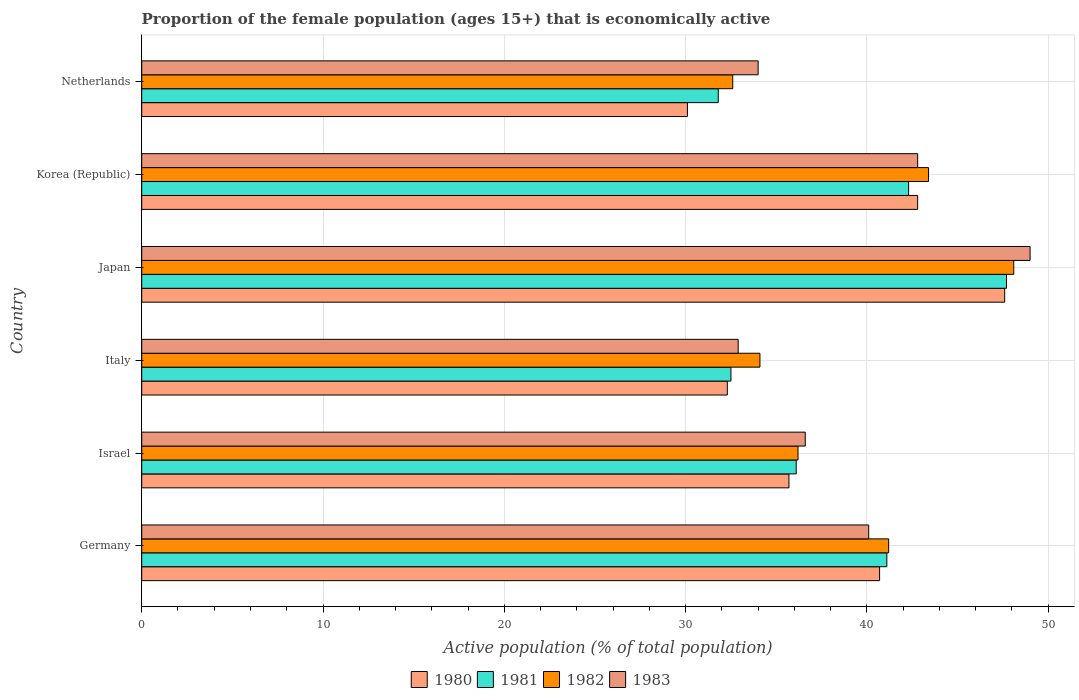In how many cases, is the number of bars for a given country not equal to the number of legend labels?
Your answer should be very brief. 0. What is the proportion of the female population that is economically active in 1983 in Germany?
Make the answer very short. 40.1. Across all countries, what is the maximum proportion of the female population that is economically active in 1982?
Your response must be concise. 48.1. Across all countries, what is the minimum proportion of the female population that is economically active in 1983?
Offer a terse response. 32.9. In which country was the proportion of the female population that is economically active in 1982 maximum?
Give a very brief answer. Japan. What is the total proportion of the female population that is economically active in 1982 in the graph?
Provide a short and direct response. 235.6. What is the difference between the proportion of the female population that is economically active in 1980 in Germany and that in Korea (Republic)?
Offer a terse response. -2.1. What is the difference between the proportion of the female population that is economically active in 1981 in Israel and the proportion of the female population that is economically active in 1980 in Germany?
Give a very brief answer. -4.6. What is the average proportion of the female population that is economically active in 1982 per country?
Your answer should be very brief. 39.27. What is the difference between the proportion of the female population that is economically active in 1983 and proportion of the female population that is economically active in 1982 in Germany?
Keep it short and to the point. -1.1. In how many countries, is the proportion of the female population that is economically active in 1980 greater than 6 %?
Offer a terse response. 6. What is the ratio of the proportion of the female population that is economically active in 1983 in Italy to that in Korea (Republic)?
Give a very brief answer. 0.77. Is the proportion of the female population that is economically active in 1983 in Germany less than that in Korea (Republic)?
Keep it short and to the point. Yes. What is the difference between the highest and the second highest proportion of the female population that is economically active in 1982?
Your response must be concise. 4.7. What is the difference between the highest and the lowest proportion of the female population that is economically active in 1980?
Your answer should be very brief. 17.5. In how many countries, is the proportion of the female population that is economically active in 1981 greater than the average proportion of the female population that is economically active in 1981 taken over all countries?
Ensure brevity in your answer.  3. Is the sum of the proportion of the female population that is economically active in 1982 in Korea (Republic) and Netherlands greater than the maximum proportion of the female population that is economically active in 1980 across all countries?
Your answer should be very brief. Yes. What does the 1st bar from the bottom in Korea (Republic) represents?
Your answer should be very brief. 1980. Is it the case that in every country, the sum of the proportion of the female population that is economically active in 1981 and proportion of the female population that is economically active in 1980 is greater than the proportion of the female population that is economically active in 1982?
Offer a terse response. Yes. How many bars are there?
Your answer should be very brief. 24. How many countries are there in the graph?
Keep it short and to the point. 6. What is the difference between two consecutive major ticks on the X-axis?
Offer a terse response. 10. Does the graph contain grids?
Offer a very short reply. Yes. Where does the legend appear in the graph?
Your response must be concise. Bottom center. How are the legend labels stacked?
Make the answer very short. Horizontal. What is the title of the graph?
Give a very brief answer. Proportion of the female population (ages 15+) that is economically active. Does "1973" appear as one of the legend labels in the graph?
Make the answer very short. No. What is the label or title of the X-axis?
Offer a terse response. Active population (% of total population). What is the label or title of the Y-axis?
Make the answer very short. Country. What is the Active population (% of total population) of 1980 in Germany?
Offer a very short reply. 40.7. What is the Active population (% of total population) of 1981 in Germany?
Ensure brevity in your answer.  41.1. What is the Active population (% of total population) of 1982 in Germany?
Make the answer very short. 41.2. What is the Active population (% of total population) in 1983 in Germany?
Keep it short and to the point. 40.1. What is the Active population (% of total population) of 1980 in Israel?
Make the answer very short. 35.7. What is the Active population (% of total population) of 1981 in Israel?
Offer a very short reply. 36.1. What is the Active population (% of total population) in 1982 in Israel?
Provide a short and direct response. 36.2. What is the Active population (% of total population) of 1983 in Israel?
Provide a succinct answer. 36.6. What is the Active population (% of total population) of 1980 in Italy?
Ensure brevity in your answer.  32.3. What is the Active population (% of total population) in 1981 in Italy?
Give a very brief answer. 32.5. What is the Active population (% of total population) of 1982 in Italy?
Make the answer very short. 34.1. What is the Active population (% of total population) in 1983 in Italy?
Provide a short and direct response. 32.9. What is the Active population (% of total population) of 1980 in Japan?
Make the answer very short. 47.6. What is the Active population (% of total population) of 1981 in Japan?
Keep it short and to the point. 47.7. What is the Active population (% of total population) in 1982 in Japan?
Your answer should be compact. 48.1. What is the Active population (% of total population) in 1980 in Korea (Republic)?
Your response must be concise. 42.8. What is the Active population (% of total population) of 1981 in Korea (Republic)?
Your answer should be very brief. 42.3. What is the Active population (% of total population) in 1982 in Korea (Republic)?
Give a very brief answer. 43.4. What is the Active population (% of total population) of 1983 in Korea (Republic)?
Give a very brief answer. 42.8. What is the Active population (% of total population) of 1980 in Netherlands?
Offer a very short reply. 30.1. What is the Active population (% of total population) in 1981 in Netherlands?
Give a very brief answer. 31.8. What is the Active population (% of total population) in 1982 in Netherlands?
Provide a short and direct response. 32.6. Across all countries, what is the maximum Active population (% of total population) of 1980?
Provide a short and direct response. 47.6. Across all countries, what is the maximum Active population (% of total population) of 1981?
Keep it short and to the point. 47.7. Across all countries, what is the maximum Active population (% of total population) in 1982?
Offer a terse response. 48.1. Across all countries, what is the maximum Active population (% of total population) of 1983?
Offer a terse response. 49. Across all countries, what is the minimum Active population (% of total population) in 1980?
Your answer should be compact. 30.1. Across all countries, what is the minimum Active population (% of total population) of 1981?
Your answer should be very brief. 31.8. Across all countries, what is the minimum Active population (% of total population) in 1982?
Make the answer very short. 32.6. Across all countries, what is the minimum Active population (% of total population) in 1983?
Ensure brevity in your answer.  32.9. What is the total Active population (% of total population) in 1980 in the graph?
Give a very brief answer. 229.2. What is the total Active population (% of total population) of 1981 in the graph?
Your answer should be compact. 231.5. What is the total Active population (% of total population) in 1982 in the graph?
Provide a succinct answer. 235.6. What is the total Active population (% of total population) of 1983 in the graph?
Give a very brief answer. 235.4. What is the difference between the Active population (% of total population) in 1981 in Germany and that in Israel?
Offer a very short reply. 5. What is the difference between the Active population (% of total population) of 1982 in Germany and that in Israel?
Give a very brief answer. 5. What is the difference between the Active population (% of total population) of 1983 in Germany and that in Israel?
Offer a terse response. 3.5. What is the difference between the Active population (% of total population) in 1981 in Germany and that in Italy?
Keep it short and to the point. 8.6. What is the difference between the Active population (% of total population) of 1983 in Germany and that in Italy?
Your response must be concise. 7.2. What is the difference between the Active population (% of total population) of 1981 in Germany and that in Japan?
Make the answer very short. -6.6. What is the difference between the Active population (% of total population) of 1983 in Germany and that in Japan?
Offer a very short reply. -8.9. What is the difference between the Active population (% of total population) in 1980 in Germany and that in Netherlands?
Offer a terse response. 10.6. What is the difference between the Active population (% of total population) of 1982 in Germany and that in Netherlands?
Offer a very short reply. 8.6. What is the difference between the Active population (% of total population) in 1982 in Israel and that in Italy?
Provide a short and direct response. 2.1. What is the difference between the Active population (% of total population) of 1983 in Israel and that in Italy?
Provide a succinct answer. 3.7. What is the difference between the Active population (% of total population) of 1981 in Israel and that in Japan?
Your answer should be very brief. -11.6. What is the difference between the Active population (% of total population) of 1980 in Israel and that in Netherlands?
Offer a terse response. 5.6. What is the difference between the Active population (% of total population) of 1981 in Israel and that in Netherlands?
Offer a terse response. 4.3. What is the difference between the Active population (% of total population) of 1982 in Israel and that in Netherlands?
Provide a short and direct response. 3.6. What is the difference between the Active population (% of total population) of 1980 in Italy and that in Japan?
Your answer should be very brief. -15.3. What is the difference between the Active population (% of total population) of 1981 in Italy and that in Japan?
Your answer should be very brief. -15.2. What is the difference between the Active population (% of total population) of 1982 in Italy and that in Japan?
Give a very brief answer. -14. What is the difference between the Active population (% of total population) in 1983 in Italy and that in Japan?
Ensure brevity in your answer.  -16.1. What is the difference between the Active population (% of total population) of 1983 in Italy and that in Korea (Republic)?
Provide a succinct answer. -9.9. What is the difference between the Active population (% of total population) of 1981 in Italy and that in Netherlands?
Your answer should be very brief. 0.7. What is the difference between the Active population (% of total population) in 1982 in Italy and that in Netherlands?
Offer a very short reply. 1.5. What is the difference between the Active population (% of total population) of 1983 in Italy and that in Netherlands?
Provide a succinct answer. -1.1. What is the difference between the Active population (% of total population) in 1980 in Japan and that in Korea (Republic)?
Ensure brevity in your answer.  4.8. What is the difference between the Active population (% of total population) of 1983 in Japan and that in Korea (Republic)?
Offer a terse response. 6.2. What is the difference between the Active population (% of total population) in 1980 in Japan and that in Netherlands?
Offer a very short reply. 17.5. What is the difference between the Active population (% of total population) in 1981 in Japan and that in Netherlands?
Your response must be concise. 15.9. What is the difference between the Active population (% of total population) in 1980 in Korea (Republic) and that in Netherlands?
Give a very brief answer. 12.7. What is the difference between the Active population (% of total population) of 1981 in Korea (Republic) and that in Netherlands?
Provide a short and direct response. 10.5. What is the difference between the Active population (% of total population) in 1980 in Germany and the Active population (% of total population) in 1981 in Israel?
Make the answer very short. 4.6. What is the difference between the Active population (% of total population) in 1980 in Germany and the Active population (% of total population) in 1982 in Israel?
Give a very brief answer. 4.5. What is the difference between the Active population (% of total population) in 1981 in Germany and the Active population (% of total population) in 1982 in Israel?
Ensure brevity in your answer.  4.9. What is the difference between the Active population (% of total population) of 1980 in Germany and the Active population (% of total population) of 1981 in Italy?
Your answer should be compact. 8.2. What is the difference between the Active population (% of total population) in 1980 in Germany and the Active population (% of total population) in 1982 in Italy?
Your answer should be very brief. 6.6. What is the difference between the Active population (% of total population) in 1980 in Germany and the Active population (% of total population) in 1983 in Italy?
Offer a very short reply. 7.8. What is the difference between the Active population (% of total population) of 1981 in Germany and the Active population (% of total population) of 1982 in Italy?
Offer a terse response. 7. What is the difference between the Active population (% of total population) in 1981 in Germany and the Active population (% of total population) in 1983 in Italy?
Your response must be concise. 8.2. What is the difference between the Active population (% of total population) of 1982 in Germany and the Active population (% of total population) of 1983 in Italy?
Offer a terse response. 8.3. What is the difference between the Active population (% of total population) in 1980 in Germany and the Active population (% of total population) in 1981 in Japan?
Offer a terse response. -7. What is the difference between the Active population (% of total population) of 1980 in Germany and the Active population (% of total population) of 1982 in Japan?
Your answer should be compact. -7.4. What is the difference between the Active population (% of total population) of 1980 in Germany and the Active population (% of total population) of 1983 in Japan?
Provide a short and direct response. -8.3. What is the difference between the Active population (% of total population) in 1982 in Germany and the Active population (% of total population) in 1983 in Japan?
Make the answer very short. -7.8. What is the difference between the Active population (% of total population) of 1980 in Germany and the Active population (% of total population) of 1981 in Korea (Republic)?
Offer a terse response. -1.6. What is the difference between the Active population (% of total population) of 1982 in Germany and the Active population (% of total population) of 1983 in Korea (Republic)?
Keep it short and to the point. -1.6. What is the difference between the Active population (% of total population) of 1980 in Germany and the Active population (% of total population) of 1981 in Netherlands?
Offer a terse response. 8.9. What is the difference between the Active population (% of total population) in 1980 in Germany and the Active population (% of total population) in 1982 in Netherlands?
Ensure brevity in your answer.  8.1. What is the difference between the Active population (% of total population) of 1980 in Germany and the Active population (% of total population) of 1983 in Netherlands?
Provide a short and direct response. 6.7. What is the difference between the Active population (% of total population) in 1982 in Germany and the Active population (% of total population) in 1983 in Netherlands?
Keep it short and to the point. 7.2. What is the difference between the Active population (% of total population) in 1980 in Israel and the Active population (% of total population) in 1981 in Italy?
Your response must be concise. 3.2. What is the difference between the Active population (% of total population) of 1980 in Israel and the Active population (% of total population) of 1982 in Italy?
Offer a very short reply. 1.6. What is the difference between the Active population (% of total population) in 1981 in Israel and the Active population (% of total population) in 1983 in Italy?
Offer a very short reply. 3.2. What is the difference between the Active population (% of total population) of 1982 in Israel and the Active population (% of total population) of 1983 in Italy?
Your response must be concise. 3.3. What is the difference between the Active population (% of total population) in 1980 in Israel and the Active population (% of total population) in 1983 in Japan?
Provide a short and direct response. -13.3. What is the difference between the Active population (% of total population) in 1981 in Israel and the Active population (% of total population) in 1983 in Japan?
Give a very brief answer. -12.9. What is the difference between the Active population (% of total population) of 1980 in Israel and the Active population (% of total population) of 1981 in Korea (Republic)?
Provide a succinct answer. -6.6. What is the difference between the Active population (% of total population) of 1980 in Israel and the Active population (% of total population) of 1982 in Korea (Republic)?
Offer a very short reply. -7.7. What is the difference between the Active population (% of total population) in 1980 in Israel and the Active population (% of total population) in 1983 in Korea (Republic)?
Keep it short and to the point. -7.1. What is the difference between the Active population (% of total population) in 1981 in Israel and the Active population (% of total population) in 1982 in Korea (Republic)?
Ensure brevity in your answer.  -7.3. What is the difference between the Active population (% of total population) of 1981 in Israel and the Active population (% of total population) of 1983 in Korea (Republic)?
Give a very brief answer. -6.7. What is the difference between the Active population (% of total population) in 1980 in Israel and the Active population (% of total population) in 1983 in Netherlands?
Provide a succinct answer. 1.7. What is the difference between the Active population (% of total population) of 1981 in Israel and the Active population (% of total population) of 1983 in Netherlands?
Ensure brevity in your answer.  2.1. What is the difference between the Active population (% of total population) of 1982 in Israel and the Active population (% of total population) of 1983 in Netherlands?
Provide a succinct answer. 2.2. What is the difference between the Active population (% of total population) in 1980 in Italy and the Active population (% of total population) in 1981 in Japan?
Offer a terse response. -15.4. What is the difference between the Active population (% of total population) of 1980 in Italy and the Active population (% of total population) of 1982 in Japan?
Keep it short and to the point. -15.8. What is the difference between the Active population (% of total population) of 1980 in Italy and the Active population (% of total population) of 1983 in Japan?
Keep it short and to the point. -16.7. What is the difference between the Active population (% of total population) of 1981 in Italy and the Active population (% of total population) of 1982 in Japan?
Provide a short and direct response. -15.6. What is the difference between the Active population (% of total population) of 1981 in Italy and the Active population (% of total population) of 1983 in Japan?
Your answer should be very brief. -16.5. What is the difference between the Active population (% of total population) of 1982 in Italy and the Active population (% of total population) of 1983 in Japan?
Keep it short and to the point. -14.9. What is the difference between the Active population (% of total population) of 1980 in Italy and the Active population (% of total population) of 1983 in Korea (Republic)?
Make the answer very short. -10.5. What is the difference between the Active population (% of total population) in 1981 in Italy and the Active population (% of total population) in 1982 in Korea (Republic)?
Your answer should be very brief. -10.9. What is the difference between the Active population (% of total population) of 1982 in Italy and the Active population (% of total population) of 1983 in Korea (Republic)?
Make the answer very short. -8.7. What is the difference between the Active population (% of total population) in 1980 in Italy and the Active population (% of total population) in 1981 in Netherlands?
Offer a terse response. 0.5. What is the difference between the Active population (% of total population) of 1981 in Italy and the Active population (% of total population) of 1983 in Netherlands?
Provide a succinct answer. -1.5. What is the difference between the Active population (% of total population) of 1982 in Italy and the Active population (% of total population) of 1983 in Netherlands?
Your response must be concise. 0.1. What is the difference between the Active population (% of total population) of 1980 in Japan and the Active population (% of total population) of 1981 in Korea (Republic)?
Give a very brief answer. 5.3. What is the difference between the Active population (% of total population) in 1981 in Japan and the Active population (% of total population) in 1982 in Korea (Republic)?
Provide a succinct answer. 4.3. What is the difference between the Active population (% of total population) of 1982 in Japan and the Active population (% of total population) of 1983 in Korea (Republic)?
Make the answer very short. 5.3. What is the difference between the Active population (% of total population) in 1980 in Japan and the Active population (% of total population) in 1983 in Netherlands?
Provide a succinct answer. 13.6. What is the difference between the Active population (% of total population) in 1981 in Japan and the Active population (% of total population) in 1982 in Netherlands?
Offer a very short reply. 15.1. What is the difference between the Active population (% of total population) in 1981 in Japan and the Active population (% of total population) in 1983 in Netherlands?
Provide a succinct answer. 13.7. What is the difference between the Active population (% of total population) of 1982 in Japan and the Active population (% of total population) of 1983 in Netherlands?
Your answer should be compact. 14.1. What is the difference between the Active population (% of total population) of 1980 in Korea (Republic) and the Active population (% of total population) of 1981 in Netherlands?
Your answer should be compact. 11. What is the difference between the Active population (% of total population) of 1980 in Korea (Republic) and the Active population (% of total population) of 1983 in Netherlands?
Offer a very short reply. 8.8. What is the difference between the Active population (% of total population) in 1981 in Korea (Republic) and the Active population (% of total population) in 1983 in Netherlands?
Your answer should be compact. 8.3. What is the average Active population (% of total population) of 1980 per country?
Ensure brevity in your answer.  38.2. What is the average Active population (% of total population) of 1981 per country?
Your response must be concise. 38.58. What is the average Active population (% of total population) of 1982 per country?
Provide a short and direct response. 39.27. What is the average Active population (% of total population) of 1983 per country?
Offer a very short reply. 39.23. What is the difference between the Active population (% of total population) of 1980 and Active population (% of total population) of 1981 in Germany?
Your answer should be compact. -0.4. What is the difference between the Active population (% of total population) in 1980 and Active population (% of total population) in 1982 in Germany?
Provide a short and direct response. -0.5. What is the difference between the Active population (% of total population) of 1980 and Active population (% of total population) of 1983 in Germany?
Your response must be concise. 0.6. What is the difference between the Active population (% of total population) in 1981 and Active population (% of total population) in 1982 in Germany?
Make the answer very short. -0.1. What is the difference between the Active population (% of total population) of 1981 and Active population (% of total population) of 1982 in Israel?
Keep it short and to the point. -0.1. What is the difference between the Active population (% of total population) of 1982 and Active population (% of total population) of 1983 in Israel?
Provide a succinct answer. -0.4. What is the difference between the Active population (% of total population) of 1980 and Active population (% of total population) of 1981 in Italy?
Your answer should be very brief. -0.2. What is the difference between the Active population (% of total population) in 1980 and Active population (% of total population) in 1981 in Japan?
Provide a short and direct response. -0.1. What is the difference between the Active population (% of total population) in 1980 and Active population (% of total population) in 1983 in Japan?
Your response must be concise. -1.4. What is the difference between the Active population (% of total population) in 1982 and Active population (% of total population) in 1983 in Japan?
Offer a very short reply. -0.9. What is the difference between the Active population (% of total population) in 1980 and Active population (% of total population) in 1982 in Korea (Republic)?
Your answer should be compact. -0.6. What is the difference between the Active population (% of total population) of 1980 and Active population (% of total population) of 1983 in Korea (Republic)?
Provide a succinct answer. 0. What is the difference between the Active population (% of total population) of 1982 and Active population (% of total population) of 1983 in Korea (Republic)?
Your response must be concise. 0.6. What is the difference between the Active population (% of total population) of 1980 and Active population (% of total population) of 1983 in Netherlands?
Offer a terse response. -3.9. What is the ratio of the Active population (% of total population) in 1980 in Germany to that in Israel?
Offer a very short reply. 1.14. What is the ratio of the Active population (% of total population) in 1981 in Germany to that in Israel?
Your answer should be compact. 1.14. What is the ratio of the Active population (% of total population) in 1982 in Germany to that in Israel?
Provide a short and direct response. 1.14. What is the ratio of the Active population (% of total population) in 1983 in Germany to that in Israel?
Your response must be concise. 1.1. What is the ratio of the Active population (% of total population) in 1980 in Germany to that in Italy?
Offer a terse response. 1.26. What is the ratio of the Active population (% of total population) of 1981 in Germany to that in Italy?
Ensure brevity in your answer.  1.26. What is the ratio of the Active population (% of total population) of 1982 in Germany to that in Italy?
Provide a succinct answer. 1.21. What is the ratio of the Active population (% of total population) of 1983 in Germany to that in Italy?
Your answer should be compact. 1.22. What is the ratio of the Active population (% of total population) in 1980 in Germany to that in Japan?
Ensure brevity in your answer.  0.85. What is the ratio of the Active population (% of total population) of 1981 in Germany to that in Japan?
Offer a terse response. 0.86. What is the ratio of the Active population (% of total population) of 1982 in Germany to that in Japan?
Provide a short and direct response. 0.86. What is the ratio of the Active population (% of total population) of 1983 in Germany to that in Japan?
Offer a terse response. 0.82. What is the ratio of the Active population (% of total population) in 1980 in Germany to that in Korea (Republic)?
Give a very brief answer. 0.95. What is the ratio of the Active population (% of total population) in 1981 in Germany to that in Korea (Republic)?
Keep it short and to the point. 0.97. What is the ratio of the Active population (% of total population) of 1982 in Germany to that in Korea (Republic)?
Your answer should be compact. 0.95. What is the ratio of the Active population (% of total population) in 1983 in Germany to that in Korea (Republic)?
Ensure brevity in your answer.  0.94. What is the ratio of the Active population (% of total population) in 1980 in Germany to that in Netherlands?
Keep it short and to the point. 1.35. What is the ratio of the Active population (% of total population) of 1981 in Germany to that in Netherlands?
Offer a very short reply. 1.29. What is the ratio of the Active population (% of total population) of 1982 in Germany to that in Netherlands?
Keep it short and to the point. 1.26. What is the ratio of the Active population (% of total population) of 1983 in Germany to that in Netherlands?
Make the answer very short. 1.18. What is the ratio of the Active population (% of total population) in 1980 in Israel to that in Italy?
Provide a succinct answer. 1.11. What is the ratio of the Active population (% of total population) of 1981 in Israel to that in Italy?
Your response must be concise. 1.11. What is the ratio of the Active population (% of total population) of 1982 in Israel to that in Italy?
Your response must be concise. 1.06. What is the ratio of the Active population (% of total population) in 1983 in Israel to that in Italy?
Ensure brevity in your answer.  1.11. What is the ratio of the Active population (% of total population) in 1981 in Israel to that in Japan?
Offer a terse response. 0.76. What is the ratio of the Active population (% of total population) of 1982 in Israel to that in Japan?
Provide a short and direct response. 0.75. What is the ratio of the Active population (% of total population) in 1983 in Israel to that in Japan?
Your response must be concise. 0.75. What is the ratio of the Active population (% of total population) in 1980 in Israel to that in Korea (Republic)?
Offer a very short reply. 0.83. What is the ratio of the Active population (% of total population) of 1981 in Israel to that in Korea (Republic)?
Make the answer very short. 0.85. What is the ratio of the Active population (% of total population) of 1982 in Israel to that in Korea (Republic)?
Your answer should be compact. 0.83. What is the ratio of the Active population (% of total population) of 1983 in Israel to that in Korea (Republic)?
Offer a terse response. 0.86. What is the ratio of the Active population (% of total population) of 1980 in Israel to that in Netherlands?
Provide a short and direct response. 1.19. What is the ratio of the Active population (% of total population) in 1981 in Israel to that in Netherlands?
Offer a very short reply. 1.14. What is the ratio of the Active population (% of total population) of 1982 in Israel to that in Netherlands?
Your answer should be compact. 1.11. What is the ratio of the Active population (% of total population) of 1983 in Israel to that in Netherlands?
Ensure brevity in your answer.  1.08. What is the ratio of the Active population (% of total population) in 1980 in Italy to that in Japan?
Provide a succinct answer. 0.68. What is the ratio of the Active population (% of total population) of 1981 in Italy to that in Japan?
Ensure brevity in your answer.  0.68. What is the ratio of the Active population (% of total population) in 1982 in Italy to that in Japan?
Provide a short and direct response. 0.71. What is the ratio of the Active population (% of total population) in 1983 in Italy to that in Japan?
Your answer should be very brief. 0.67. What is the ratio of the Active population (% of total population) in 1980 in Italy to that in Korea (Republic)?
Your response must be concise. 0.75. What is the ratio of the Active population (% of total population) in 1981 in Italy to that in Korea (Republic)?
Your answer should be compact. 0.77. What is the ratio of the Active population (% of total population) of 1982 in Italy to that in Korea (Republic)?
Keep it short and to the point. 0.79. What is the ratio of the Active population (% of total population) of 1983 in Italy to that in Korea (Republic)?
Give a very brief answer. 0.77. What is the ratio of the Active population (% of total population) of 1980 in Italy to that in Netherlands?
Your answer should be compact. 1.07. What is the ratio of the Active population (% of total population) of 1982 in Italy to that in Netherlands?
Ensure brevity in your answer.  1.05. What is the ratio of the Active population (% of total population) in 1983 in Italy to that in Netherlands?
Make the answer very short. 0.97. What is the ratio of the Active population (% of total population) in 1980 in Japan to that in Korea (Republic)?
Ensure brevity in your answer.  1.11. What is the ratio of the Active population (% of total population) of 1981 in Japan to that in Korea (Republic)?
Provide a succinct answer. 1.13. What is the ratio of the Active population (% of total population) in 1982 in Japan to that in Korea (Republic)?
Offer a terse response. 1.11. What is the ratio of the Active population (% of total population) of 1983 in Japan to that in Korea (Republic)?
Your response must be concise. 1.14. What is the ratio of the Active population (% of total population) of 1980 in Japan to that in Netherlands?
Your answer should be compact. 1.58. What is the ratio of the Active population (% of total population) of 1981 in Japan to that in Netherlands?
Ensure brevity in your answer.  1.5. What is the ratio of the Active population (% of total population) in 1982 in Japan to that in Netherlands?
Make the answer very short. 1.48. What is the ratio of the Active population (% of total population) in 1983 in Japan to that in Netherlands?
Offer a very short reply. 1.44. What is the ratio of the Active population (% of total population) in 1980 in Korea (Republic) to that in Netherlands?
Provide a succinct answer. 1.42. What is the ratio of the Active population (% of total population) of 1981 in Korea (Republic) to that in Netherlands?
Keep it short and to the point. 1.33. What is the ratio of the Active population (% of total population) of 1982 in Korea (Republic) to that in Netherlands?
Keep it short and to the point. 1.33. What is the ratio of the Active population (% of total population) in 1983 in Korea (Republic) to that in Netherlands?
Your answer should be very brief. 1.26. What is the difference between the highest and the second highest Active population (% of total population) in 1981?
Your answer should be very brief. 5.4. What is the difference between the highest and the lowest Active population (% of total population) of 1982?
Give a very brief answer. 15.5. What is the difference between the highest and the lowest Active population (% of total population) in 1983?
Your answer should be very brief. 16.1. 